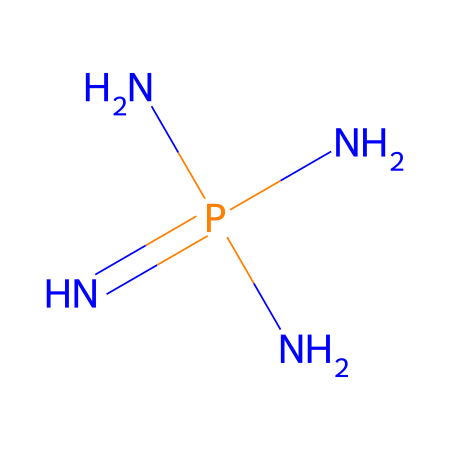What is the total number of nitrogen atoms in this chemical? The SMILES indicates that there are four nitrogen atoms present in the structure: one central nitrogen atom and three nitrogen atoms surrounding it in the phosphazene structure.
Answer: four What type of bonds are present in this chemical? The structure contains covalent bonds, specifically between the nitrogen atoms and between nitrogen and phosphorus. This is indicative of a superbase structure where N and P form strong covalent interactions.
Answer: covalent What element is at the center of this chemical's structure? The central atom in the SMILES representation is phosphorus, indicating that it is the core element around which the nitrogen atoms are arranged in the phosphazene structure.
Answer: phosphorus What is the primary application of phosphazene-based superbases? Phosphazene superbases are primarily utilized in high-performance adhesives, which are crucial for emergency vessel repairs due to their excellent bonding properties.
Answer: adhesives How many bonds does the central phosphorus atom form? The central phosphorus atom is represented by the structure as being bonded to four nitrogen atoms, thus forming four key covalent bonds which influences its chemical behavior as a superbase.
Answer: four What type of chemical is phosphazene classified as? Phosphazene is classified as a superbase because it possesses strong basicity, making it notably effective in various chemical applications, particularly in adhesive formulations.
Answer: superbase 